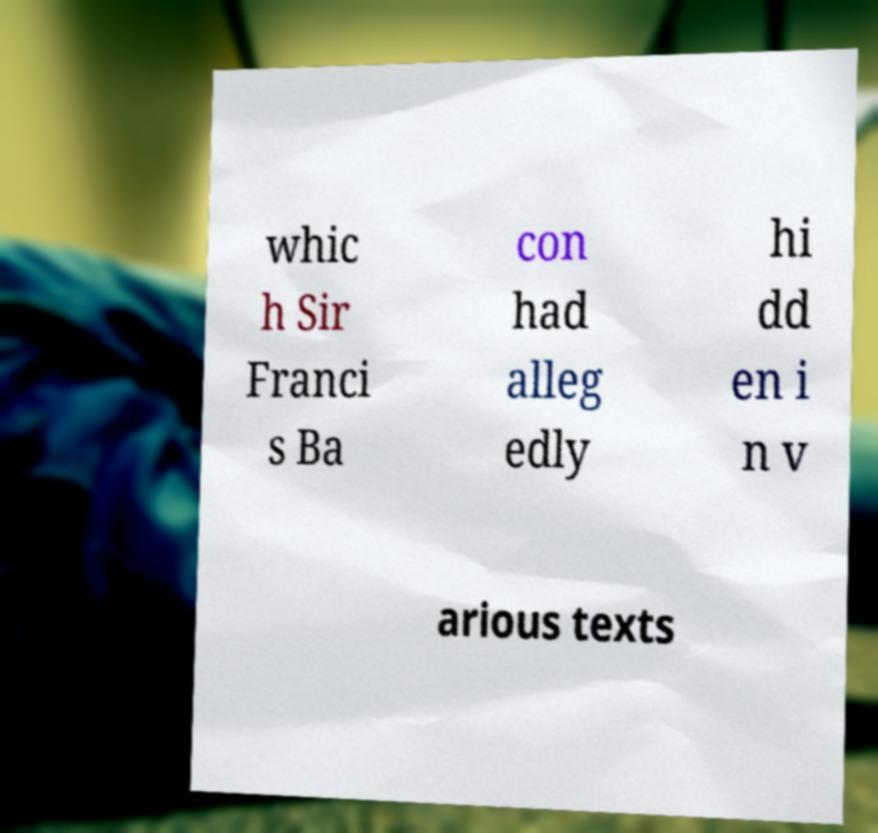What messages or text are displayed in this image? I need them in a readable, typed format. whic h Sir Franci s Ba con had alleg edly hi dd en i n v arious texts 